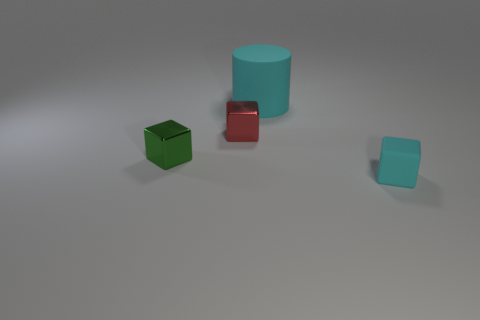Subtract all small metal blocks. How many blocks are left? 1 Add 4 tiny green shiny cylinders. How many objects exist? 8 Subtract all green blocks. How many blocks are left? 2 Subtract 0 green cylinders. How many objects are left? 4 Subtract all cylinders. How many objects are left? 3 Subtract 1 cubes. How many cubes are left? 2 Subtract all gray cylinders. Subtract all yellow spheres. How many cylinders are left? 1 Subtract all brown blocks. How many red cylinders are left? 0 Subtract all tiny green objects. Subtract all small cyan rubber cylinders. How many objects are left? 3 Add 3 cylinders. How many cylinders are left? 4 